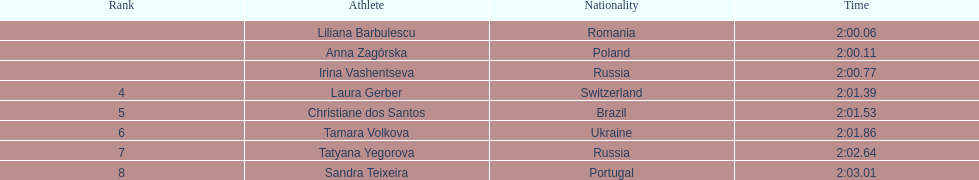What is the number of russian participants in this set of semifinals? 2. 